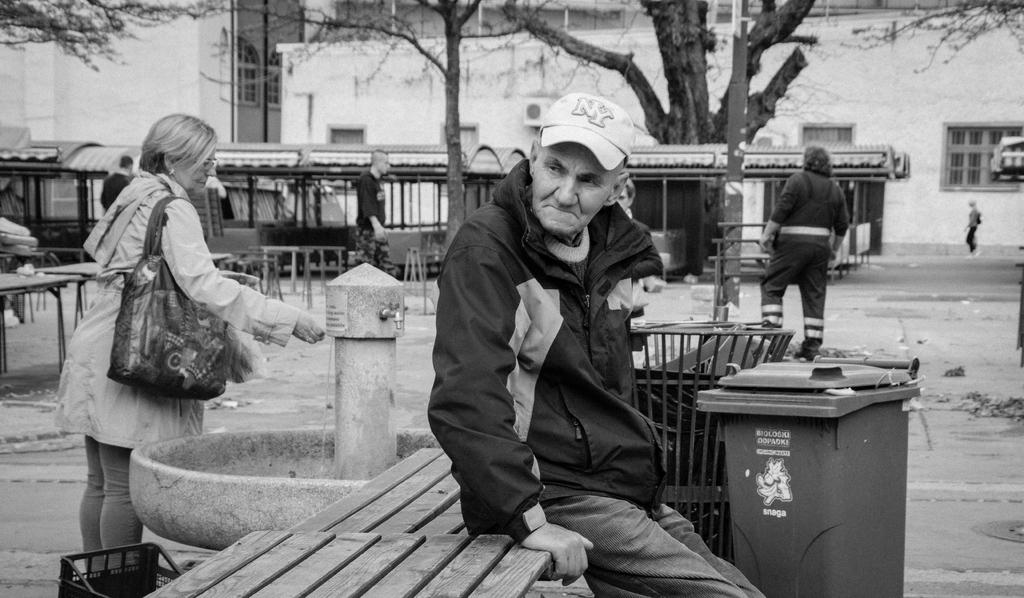<image>
Share a concise interpretation of the image provided. a man with a hat on that says NY on it 